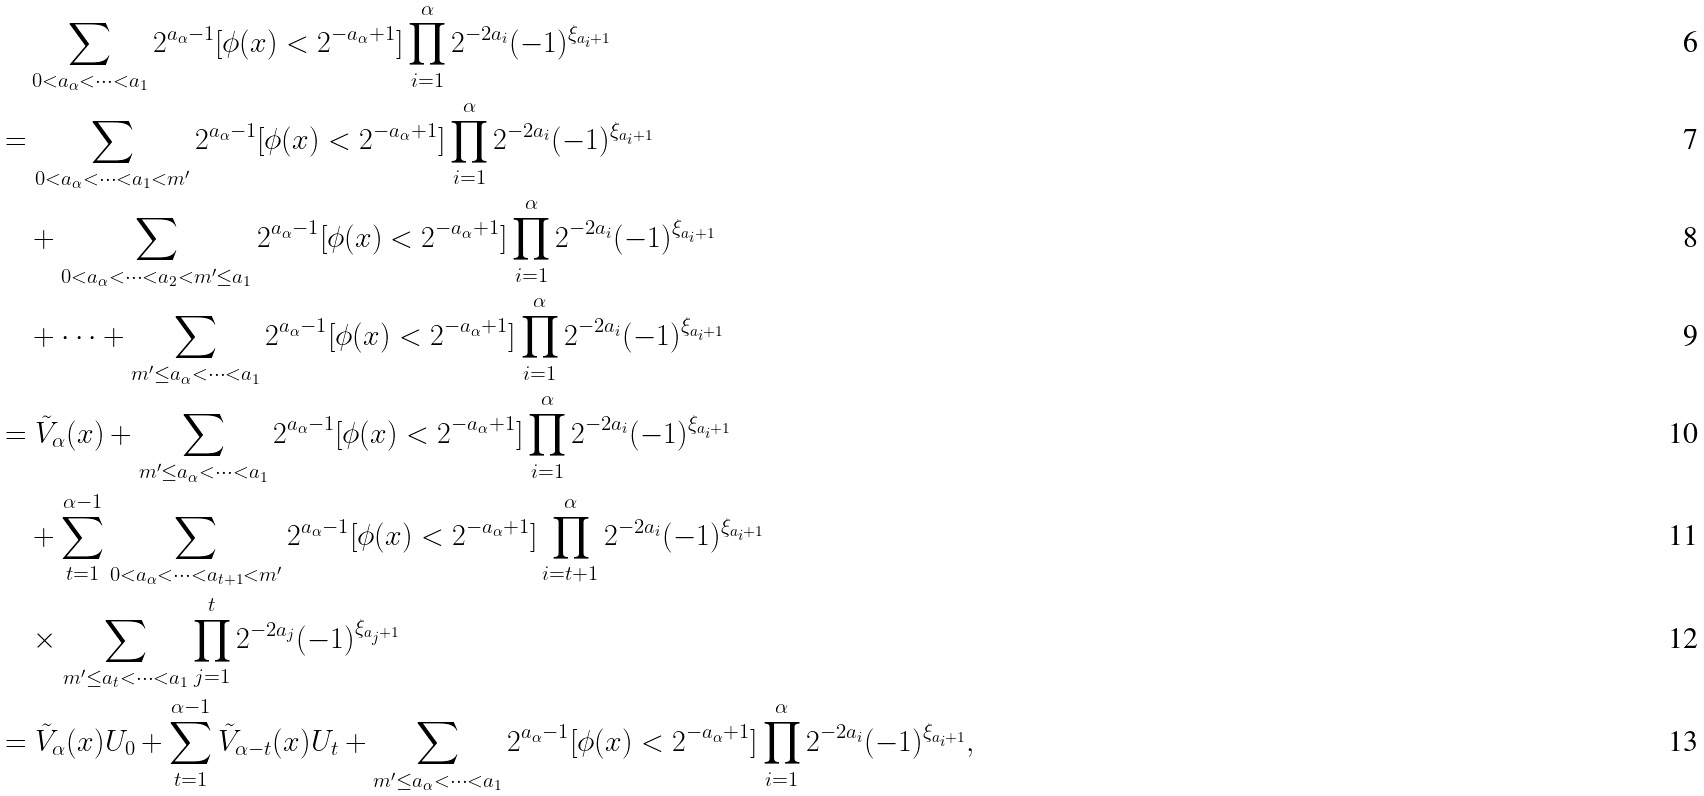Convert formula to latex. <formula><loc_0><loc_0><loc_500><loc_500>& \quad \sum _ { 0 < a _ { \alpha } < \cdots < a _ { 1 } } 2 ^ { a _ { \alpha } - 1 } [ \phi ( x ) < 2 ^ { - a _ { \alpha } + 1 } ] \prod _ { i = 1 } ^ { \alpha } 2 ^ { - 2 a _ { i } } ( - 1 ) ^ { \xi _ { a _ { i } + 1 } } \\ & = \sum _ { 0 < a _ { \alpha } < \cdots < a _ { 1 } < m ^ { \prime } } 2 ^ { a _ { \alpha } - 1 } [ \phi ( x ) < 2 ^ { - a _ { \alpha } + 1 } ] \prod _ { i = 1 } ^ { \alpha } 2 ^ { - 2 a _ { i } } ( - 1 ) ^ { \xi _ { a _ { i } + 1 } } \\ & \quad + \sum _ { 0 < a _ { \alpha } < \cdots < a _ { 2 } < m ^ { \prime } \leq a _ { 1 } } 2 ^ { a _ { \alpha } - 1 } [ \phi ( x ) < 2 ^ { - a _ { \alpha } + 1 } ] \prod _ { i = 1 } ^ { \alpha } 2 ^ { - 2 a _ { i } } ( - 1 ) ^ { \xi _ { a _ { i } + 1 } } \\ & \quad + \cdots + \sum _ { m ^ { \prime } \leq a _ { \alpha } < \cdots < a _ { 1 } } 2 ^ { a _ { \alpha } - 1 } [ \phi ( x ) < 2 ^ { - a _ { \alpha } + 1 } ] \prod _ { i = 1 } ^ { \alpha } 2 ^ { - 2 a _ { i } } ( - 1 ) ^ { \xi _ { a _ { i } + 1 } } \\ & = \tilde { V } _ { \alpha } ( x ) + \sum _ { m ^ { \prime } \leq a _ { \alpha } < \cdots < a _ { 1 } } 2 ^ { a _ { \alpha } - 1 } [ \phi ( x ) < 2 ^ { - a _ { \alpha } + 1 } ] \prod _ { i = 1 } ^ { \alpha } 2 ^ { - 2 a _ { i } } ( - 1 ) ^ { \xi _ { a _ { i } + 1 } } \\ & \quad + \sum _ { t = 1 } ^ { \alpha - 1 } \sum _ { 0 < a _ { \alpha } < \cdots < a _ { t + 1 } < m ^ { \prime } } 2 ^ { a _ { \alpha } - 1 } [ \phi ( x ) < 2 ^ { - a _ { \alpha } + 1 } ] \prod _ { i = t + 1 } ^ { \alpha } 2 ^ { - 2 a _ { i } } ( - 1 ) ^ { \xi _ { a _ { i } + 1 } } \\ & \quad \times \sum _ { m ^ { \prime } \leq a _ { t } < \cdots < a _ { 1 } } \prod _ { j = 1 } ^ { t } 2 ^ { - 2 a _ { j } } ( - 1 ) ^ { \xi _ { a _ { j } + 1 } } \\ & = \tilde { V } _ { \alpha } ( x ) U _ { 0 } + \sum _ { t = 1 } ^ { \alpha - 1 } \tilde { V } _ { \alpha - t } ( x ) U _ { t } + \sum _ { m ^ { \prime } \leq a _ { \alpha } < \cdots < a _ { 1 } } 2 ^ { a _ { \alpha } - 1 } [ \phi ( x ) < 2 ^ { - a _ { \alpha } + 1 } ] \prod _ { i = 1 } ^ { \alpha } 2 ^ { - 2 a _ { i } } ( - 1 ) ^ { \xi _ { a _ { i } + 1 } } ,</formula> 